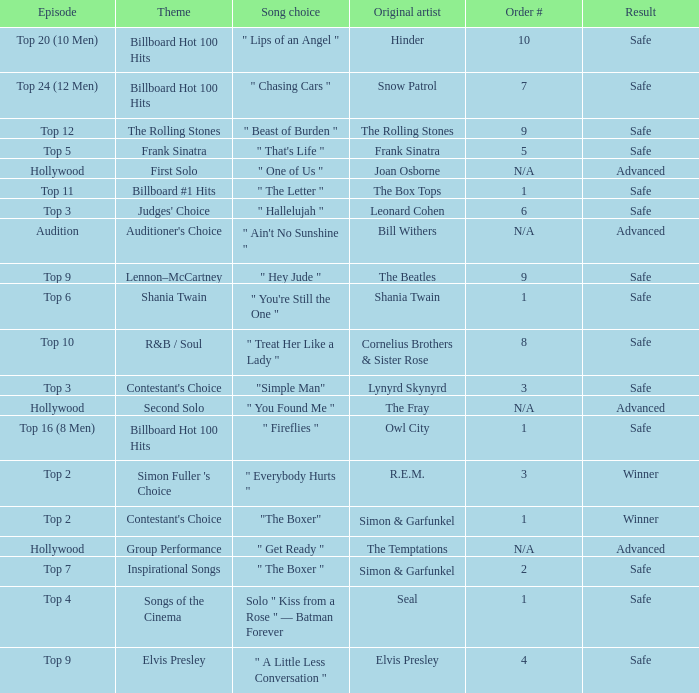In episode Top 16 (8 Men), what are the themes? Billboard Hot 100 Hits. 